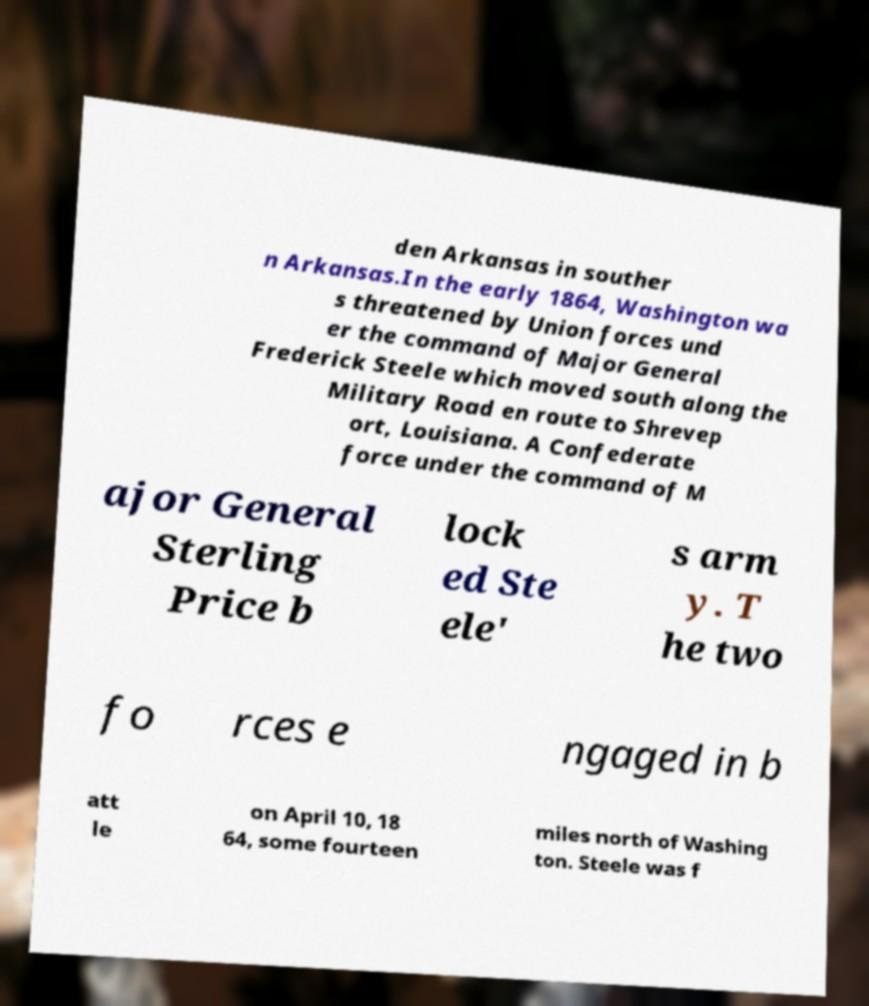Please identify and transcribe the text found in this image. den Arkansas in souther n Arkansas.In the early 1864, Washington wa s threatened by Union forces und er the command of Major General Frederick Steele which moved south along the Military Road en route to Shrevep ort, Louisiana. A Confederate force under the command of M ajor General Sterling Price b lock ed Ste ele' s arm y. T he two fo rces e ngaged in b att le on April 10, 18 64, some fourteen miles north of Washing ton. Steele was f 